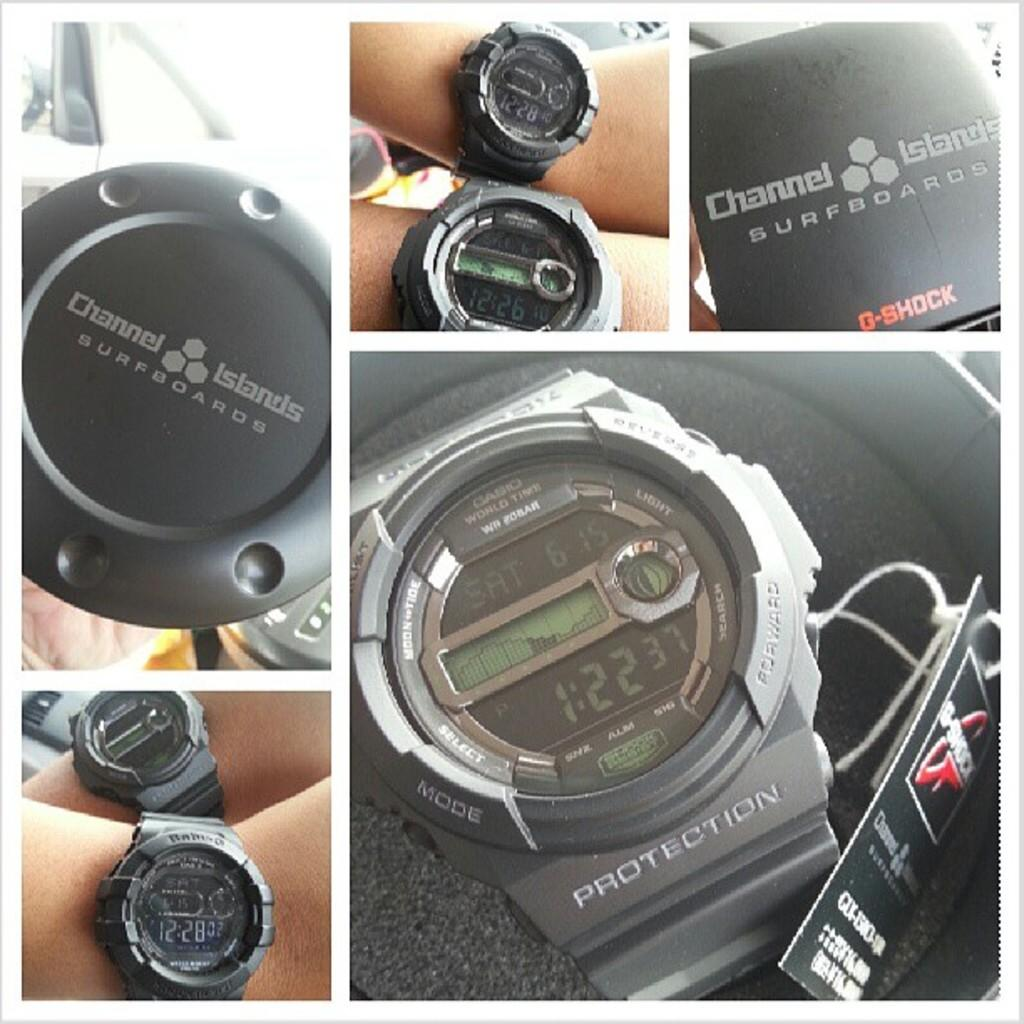<image>
Render a clear and concise summary of the photo. A watch from Channel Islands says the time is 1:22. 